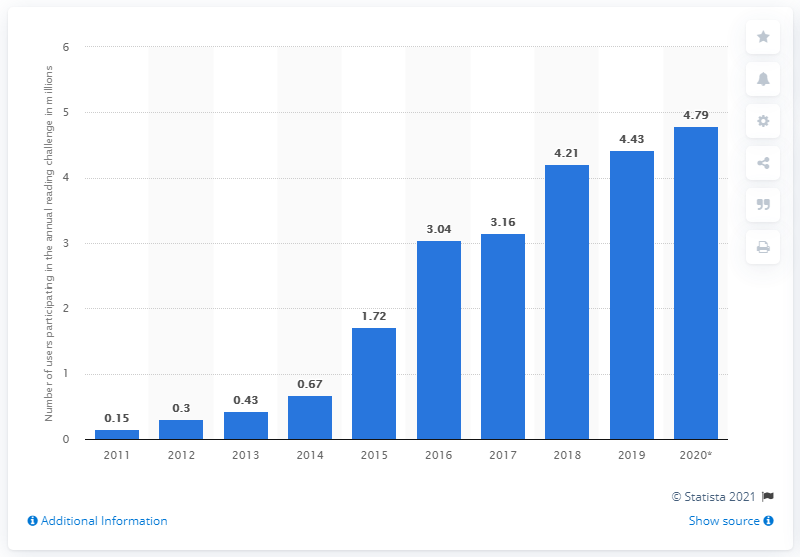Indicate a few pertinent items in this graphic. In October 2020, there were 4.79 participants in the reading challenge. In 2019, 4.43 participants signed up to track their reading progress on the social book review site. 